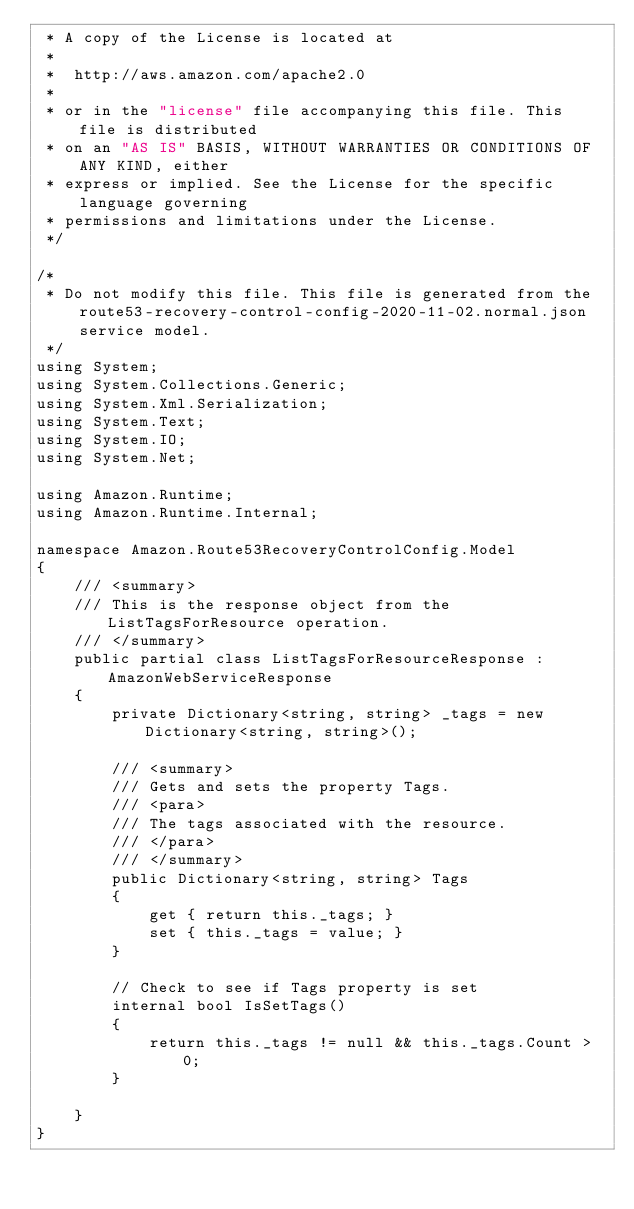Convert code to text. <code><loc_0><loc_0><loc_500><loc_500><_C#_> * A copy of the License is located at
 * 
 *  http://aws.amazon.com/apache2.0
 * 
 * or in the "license" file accompanying this file. This file is distributed
 * on an "AS IS" BASIS, WITHOUT WARRANTIES OR CONDITIONS OF ANY KIND, either
 * express or implied. See the License for the specific language governing
 * permissions and limitations under the License.
 */

/*
 * Do not modify this file. This file is generated from the route53-recovery-control-config-2020-11-02.normal.json service model.
 */
using System;
using System.Collections.Generic;
using System.Xml.Serialization;
using System.Text;
using System.IO;
using System.Net;

using Amazon.Runtime;
using Amazon.Runtime.Internal;

namespace Amazon.Route53RecoveryControlConfig.Model
{
    /// <summary>
    /// This is the response object from the ListTagsForResource operation.
    /// </summary>
    public partial class ListTagsForResourceResponse : AmazonWebServiceResponse
    {
        private Dictionary<string, string> _tags = new Dictionary<string, string>();

        /// <summary>
        /// Gets and sets the property Tags. 
        /// <para>
        /// The tags associated with the resource.
        /// </para>
        /// </summary>
        public Dictionary<string, string> Tags
        {
            get { return this._tags; }
            set { this._tags = value; }
        }

        // Check to see if Tags property is set
        internal bool IsSetTags()
        {
            return this._tags != null && this._tags.Count > 0; 
        }

    }
}</code> 